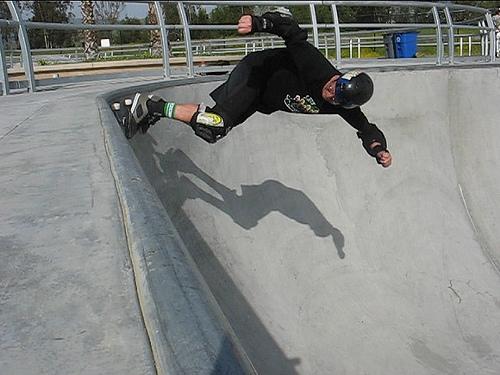What is he using as a ramp?
Short answer required. Bowl. What is the man riding on?
Quick response, please. Skateboard. Is the man falling?
Concise answer only. No. What trick is he doing?
Keep it brief. Grind. 